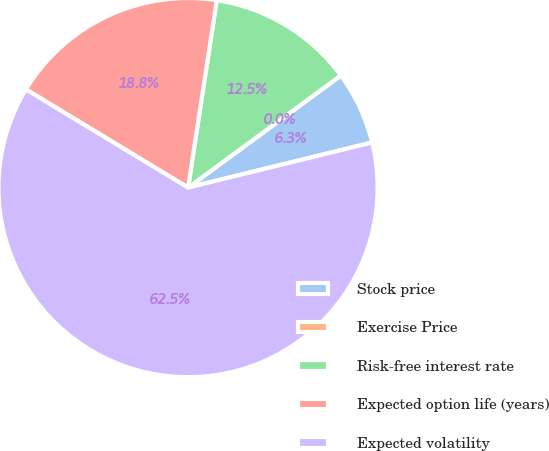Convert chart to OTSL. <chart><loc_0><loc_0><loc_500><loc_500><pie_chart><fcel>Stock price<fcel>Exercise Price<fcel>Risk-free interest rate<fcel>Expected option life (years)<fcel>Expected volatility<nl><fcel>6.25%<fcel>0.0%<fcel>12.5%<fcel>18.75%<fcel>62.49%<nl></chart> 